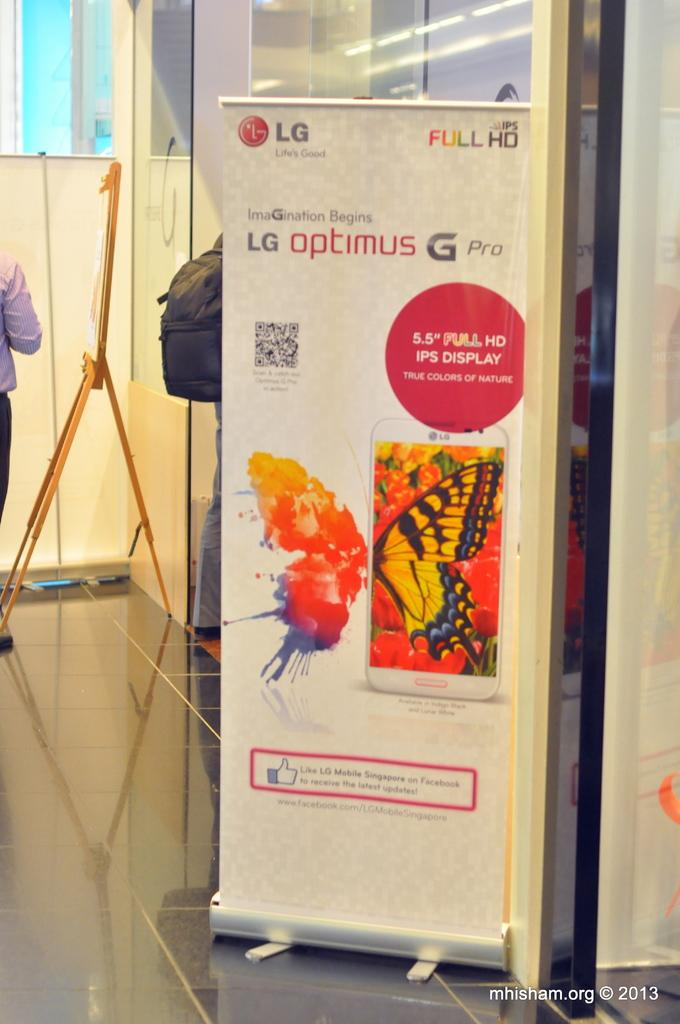<image>
Create a compact narrative representing the image presented. A banner hangs from a white metal display advertising the LG optimus G Pro. 